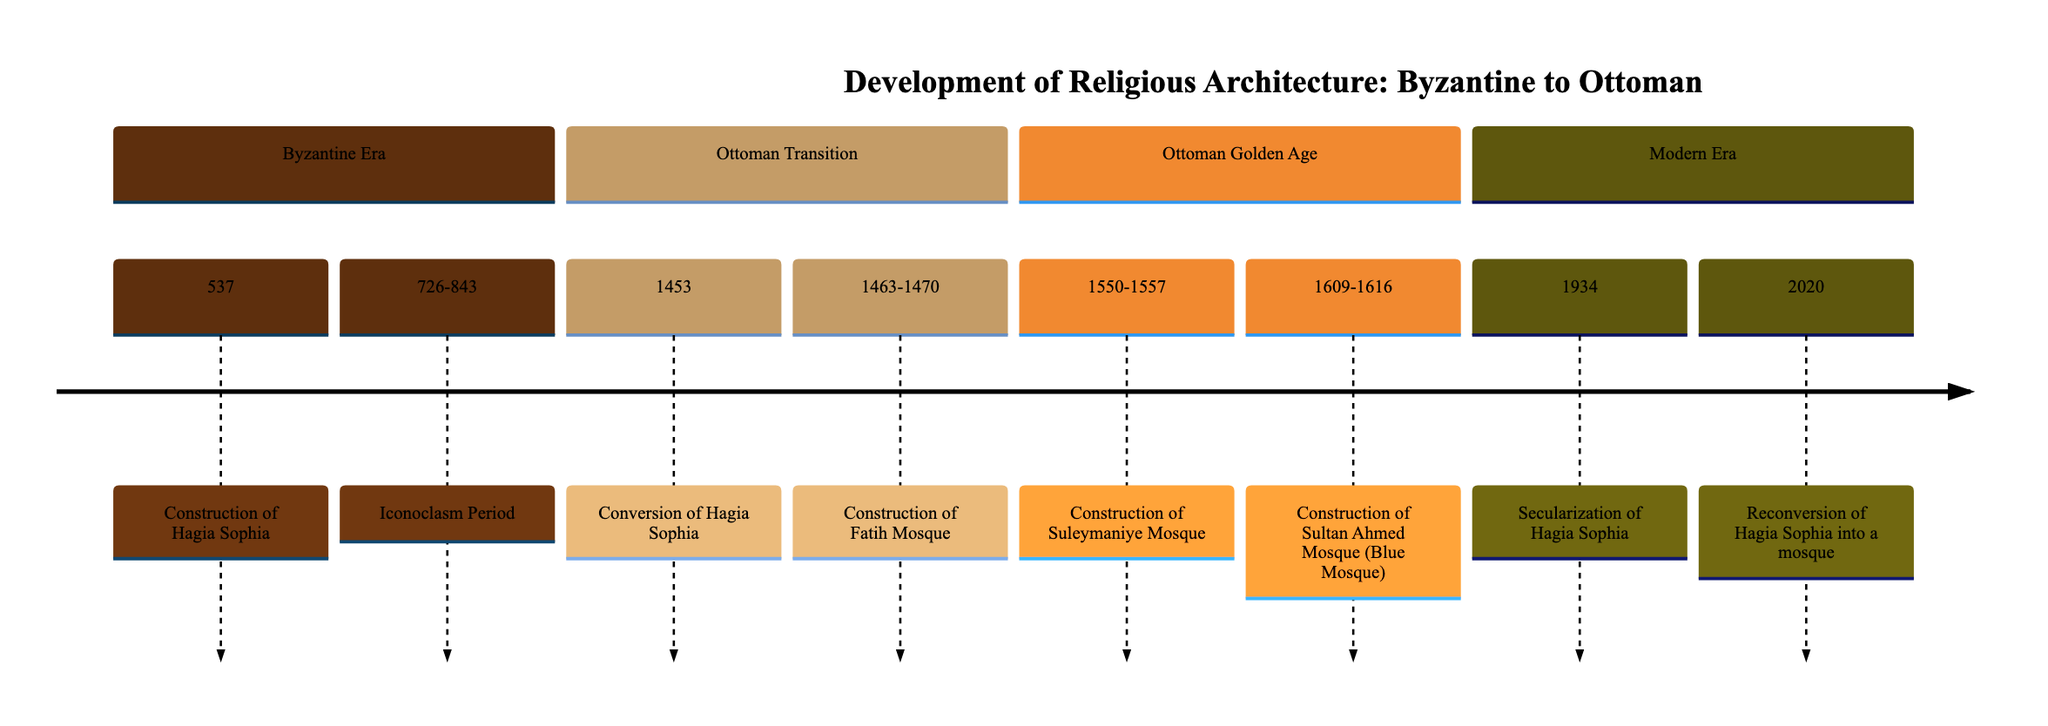What year was the Hagia Sophia completed? The timeline states that the construction of the Hagia Sophia was completed in the year 537. Therefore, the information indicates that 537 is the answer.
Answer: 537 How long did the Iconoclasm period last? The timeline indicates that the Iconoclasm period lasted from 726 to 843. To find the duration, subtract 726 from 843, resulting in 117 years.
Answer: 117 years What is the primary event in 1453? According to the timeline, the conversion of Hagia Sophia occurred in 1453 after the Ottoman conquest of Constantinople. Therefore, the event is the conversion of Hagia Sophia.
Answer: Conversion of Hagia Sophia Which mosque was built first, Fatih Mosque or Suleymaniye Mosque? The timeline lists the construction of Fatih Mosque from 1463 to 1470, and Suleymaniye Mosque from 1550 to 1557. Since 1463 comes before 1550, Fatih Mosque was built first.
Answer: Fatih Mosque What significant architectural influence is seen in the Sultan Ahmed Mosque? The timeline shows that the Sultan Ahmed Mosque, also known as the Blue Mosque, incorporates features from Hagia Sophia, particularly its dome design and other Byzantine elements. Therefore, the influence is Hagia Sophia.
Answer: Hagia Sophia What major change occurred to Hagia Sophia in 1934? The timeline notes that in 1934, Hagia Sophia was secularized and turned into a museum, marking a significant shift in its status. Therefore, the major change is its secularization.
Answer: Secularization How many mosques are mentioned in the timeline? The timeline lists three mosques: Fatih Mosque, Suleymaniye Mosque, and Sultan Ahmed Mosque (Blue Mosque). Therefore, counting them gives a total of three mosques.
Answer: 3 mosques What was the last event related to the Hagia Sophia in the timeline? The last event mentioned is the reconversion of Hagia Sophia into a mosque in 2020. This indicates the latest change regarding the structure's function.
Answer: Reconversion of Hagia Sophia into a mosque What period does the construction of the Suleymaniye Mosque fall under? The timeline categorizes the construction of the Suleymaniye Mosque from 1550 to 1557 under the Ottoman Golden Age section. Hence, it falls under the Ottoman Golden Age.
Answer: Ottoman Golden Age 